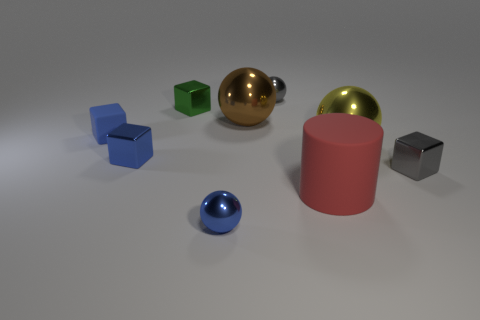Does the tiny rubber object have the same color as the small sphere to the left of the gray sphere?
Make the answer very short. Yes. Does the small shiny sphere in front of the large red matte cylinder have the same color as the cylinder?
Give a very brief answer. No. The large object that is the same material as the big yellow ball is what color?
Your response must be concise. Brown. How many balls are cyan things or brown objects?
Provide a short and direct response. 1. How many objects are either tiny purple matte balls or blue things to the right of the small blue shiny cube?
Make the answer very short. 1. Are there any tiny gray things?
Keep it short and to the point. Yes. How many tiny metallic balls are the same color as the small rubber block?
Provide a short and direct response. 1. What material is the sphere that is the same color as the matte block?
Offer a very short reply. Metal. There is a shiny ball that is on the right side of the big matte cylinder that is in front of the large yellow sphere; what size is it?
Offer a very short reply. Large. Is there a tiny gray object made of the same material as the big cylinder?
Give a very brief answer. No. 